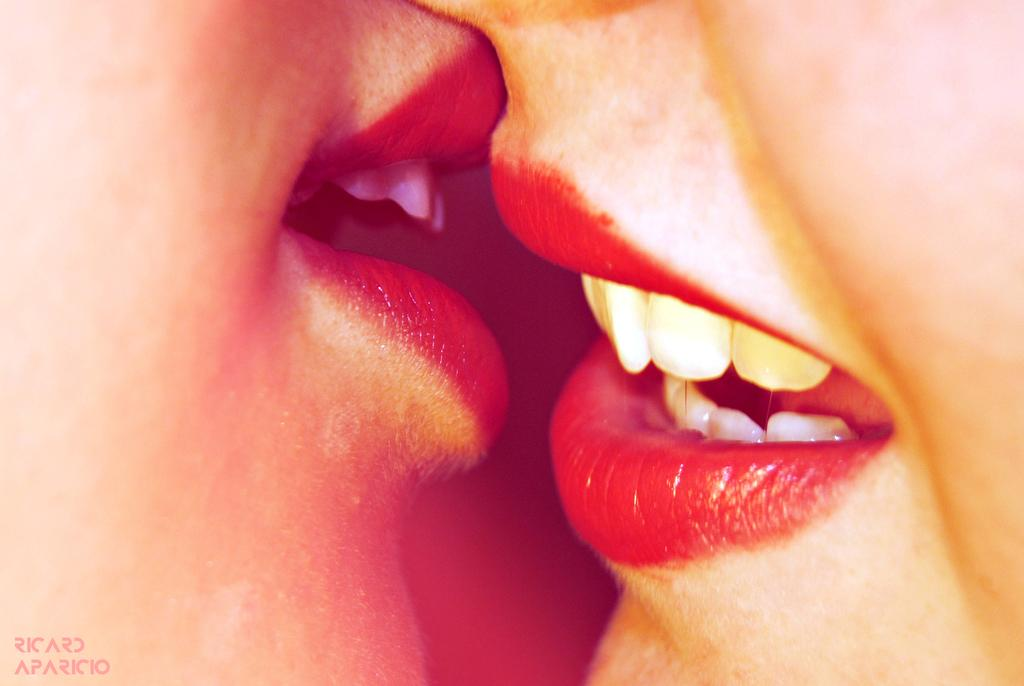How many people are in the image? There are two people in the image. What can be seen on the faces of the people in the image? The faces of the two people are visible in the image. Is there any text or marking on the image? Yes, there is a watermark on the bottom left side of the image. Which person's knee is twisted in the image? There is no mention of knees or twisting in the image; it only shows two people with visible faces. 